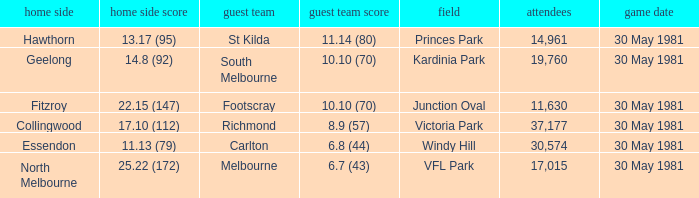What is the home venue of essendon with a crowd larger than 19,760? Windy Hill. 